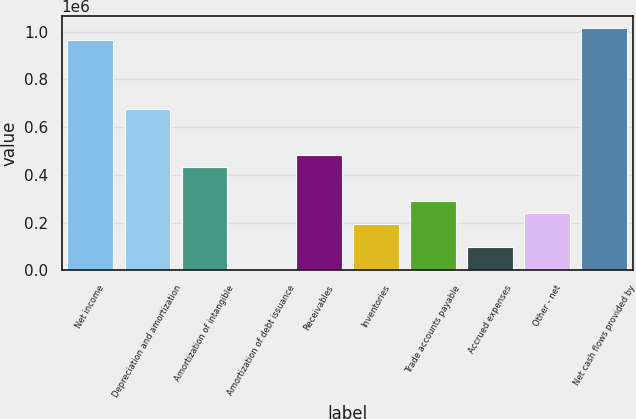Convert chart to OTSL. <chart><loc_0><loc_0><loc_500><loc_500><bar_chart><fcel>Net income<fcel>Depreciation and amortization<fcel>Amortization of intangible<fcel>Amortization of debt issuance<fcel>Receivables<fcel>Inventories<fcel>Trade accounts payable<fcel>Accrued expenses<fcel>Other - net<fcel>Net cash flows provided by<nl><fcel>965800<fcel>676146<fcel>434768<fcel>288<fcel>483044<fcel>193390<fcel>289942<fcel>96839.2<fcel>241666<fcel>1.01408e+06<nl></chart> 